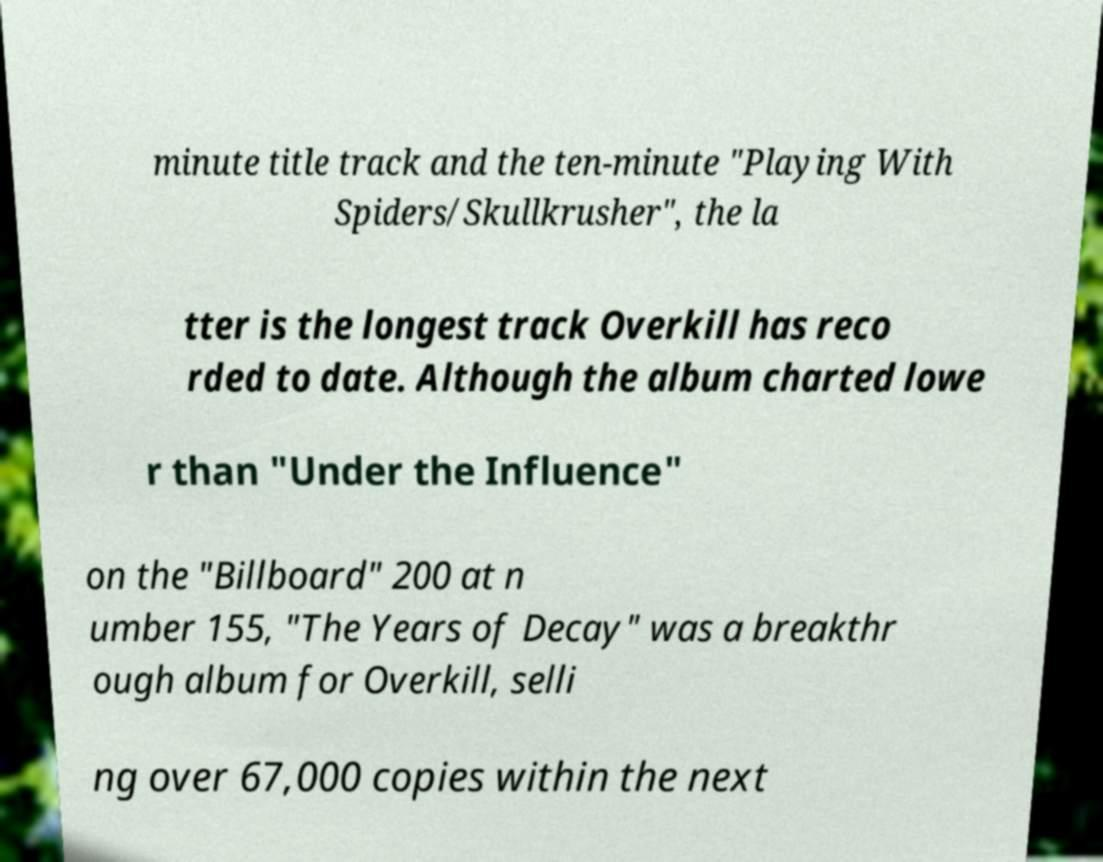There's text embedded in this image that I need extracted. Can you transcribe it verbatim? minute title track and the ten-minute "Playing With Spiders/Skullkrusher", the la tter is the longest track Overkill has reco rded to date. Although the album charted lowe r than "Under the Influence" on the "Billboard" 200 at n umber 155, "The Years of Decay" was a breakthr ough album for Overkill, selli ng over 67,000 copies within the next 